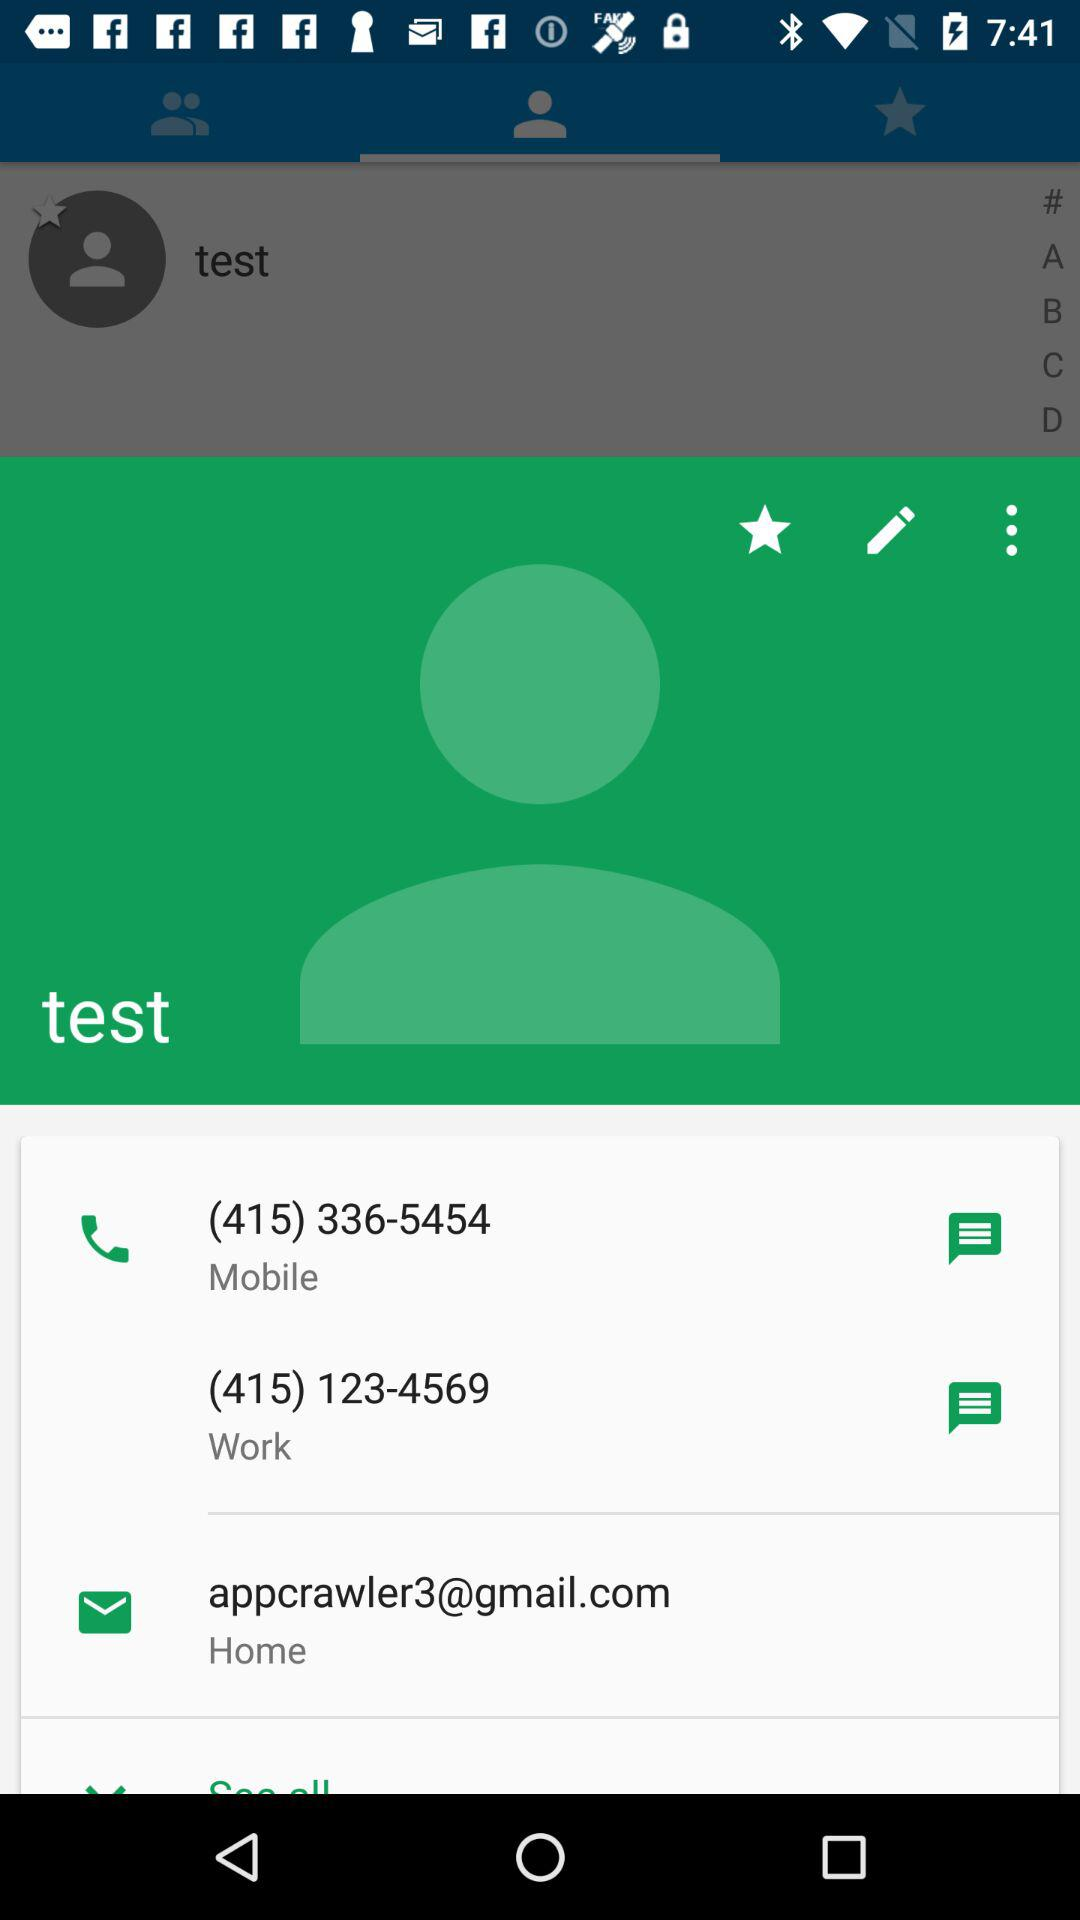What is the email address? The email address is appcrawler3@gmail.com. 